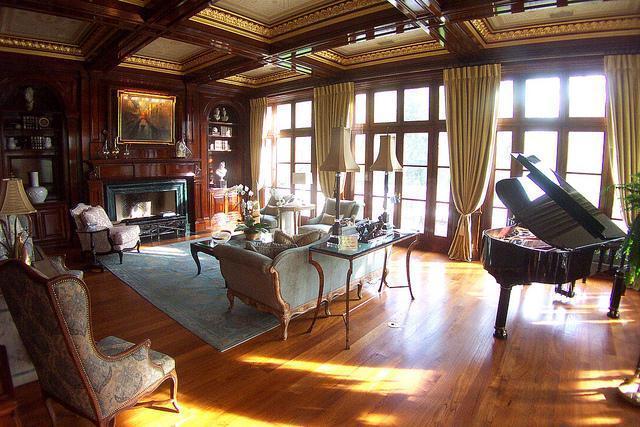How many chairs are visible?
Give a very brief answer. 2. How many people are in the water?
Give a very brief answer. 0. 